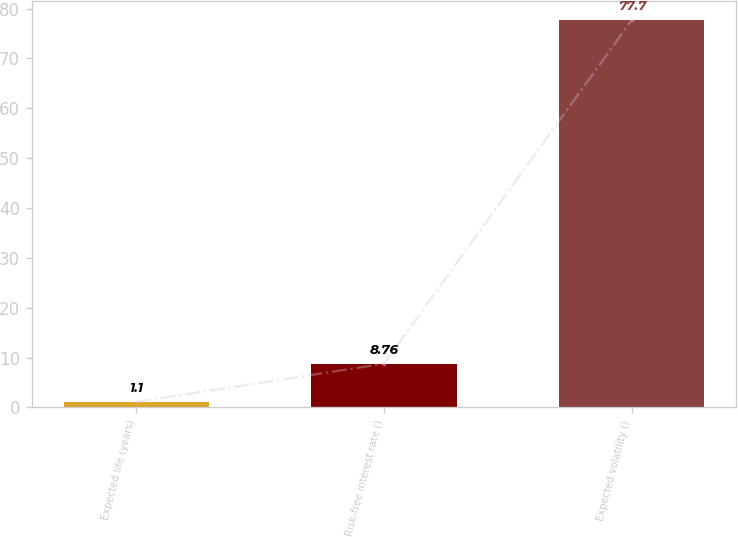Convert chart to OTSL. <chart><loc_0><loc_0><loc_500><loc_500><bar_chart><fcel>Expected life (years)<fcel>Risk-free interest rate ()<fcel>Expected volatility ()<nl><fcel>1.1<fcel>8.76<fcel>77.7<nl></chart> 